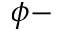Convert formula to latex. <formula><loc_0><loc_0><loc_500><loc_500>\phi -</formula> 